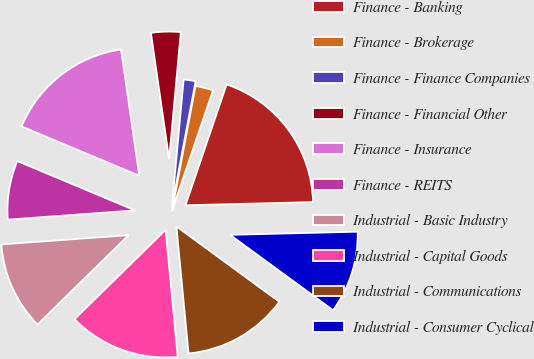Convert chart. <chart><loc_0><loc_0><loc_500><loc_500><pie_chart><fcel>Finance - Banking<fcel>Finance - Brokerage<fcel>Finance - Finance Companies<fcel>Finance - Financial Other<fcel>Finance - Insurance<fcel>Finance - REITS<fcel>Industrial - Basic Industry<fcel>Industrial - Capital Goods<fcel>Industrial - Communications<fcel>Industrial - Consumer Cyclical<nl><fcel>19.39%<fcel>2.25%<fcel>1.51%<fcel>3.74%<fcel>16.41%<fcel>7.47%<fcel>11.19%<fcel>14.17%<fcel>13.43%<fcel>10.45%<nl></chart> 